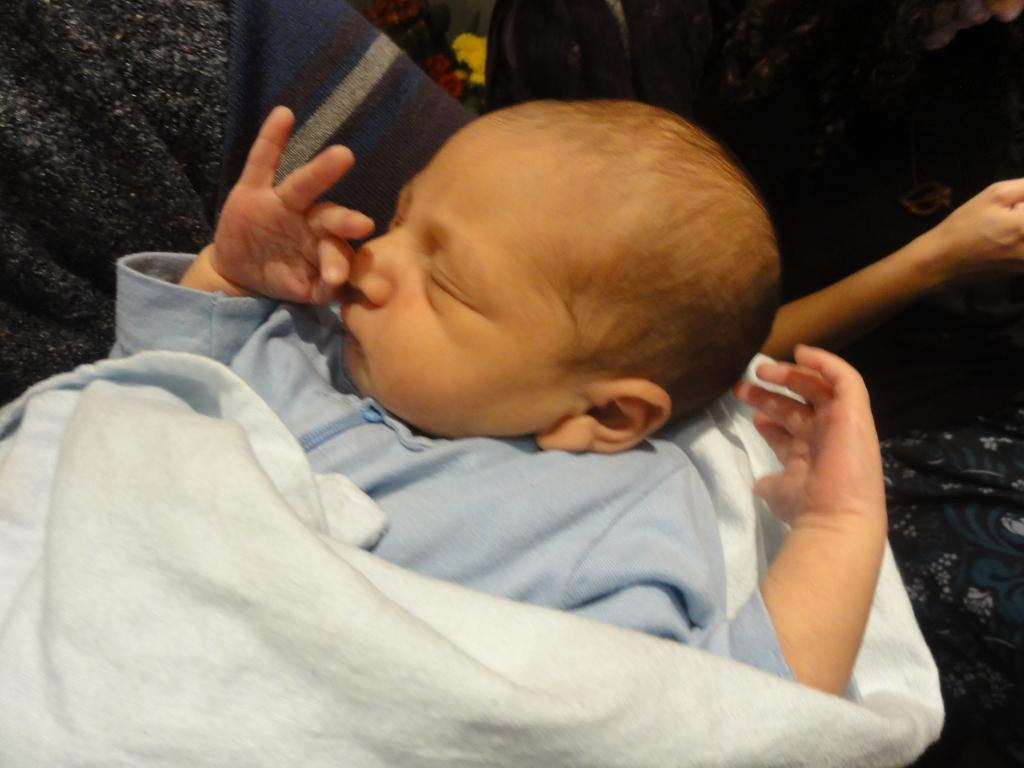What is the main subject of the image? There is a baby in the image. Where is the baby located in the image? The baby is in the front of the image. What is the baby wearing? The baby is wearing a blue dress. Can you describe the person on the right side of the image? Unfortunately, the provided facts do not mention any details about the person on the right side of the image. What type of beetle can be seen crawling on the dock in the image? There is no dock or beetle present in the image. 